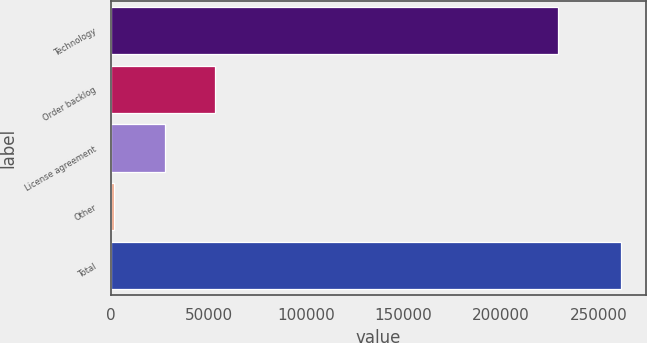Convert chart. <chart><loc_0><loc_0><loc_500><loc_500><bar_chart><fcel>Technology<fcel>Order backlog<fcel>License agreement<fcel>Other<fcel>Total<nl><fcel>228884<fcel>53519.4<fcel>27559.7<fcel>1600<fcel>261197<nl></chart> 